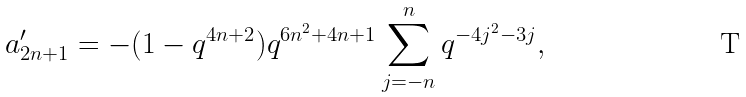Convert formula to latex. <formula><loc_0><loc_0><loc_500><loc_500>a ^ { \prime } _ { 2 n + 1 } = - ( 1 - q ^ { 4 n + 2 } ) q ^ { 6 n ^ { 2 } + 4 n + 1 } \sum _ { j = - n } ^ { n } q ^ { - 4 j ^ { 2 } - 3 j } ,</formula> 